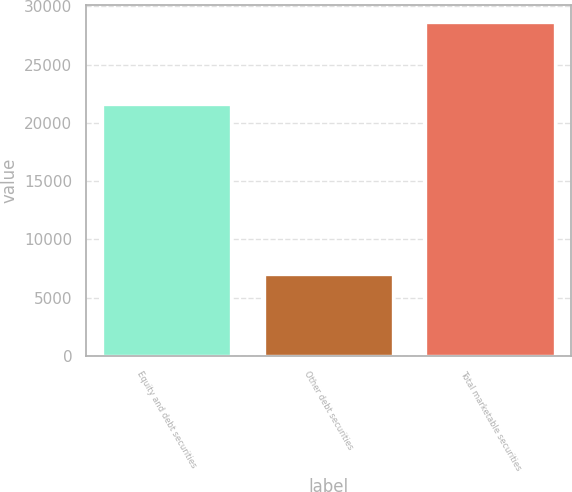Convert chart to OTSL. <chart><loc_0><loc_0><loc_500><loc_500><bar_chart><fcel>Equity and debt securities<fcel>Other debt securities<fcel>Total marketable securities<nl><fcel>21629<fcel>7042<fcel>28671<nl></chart> 